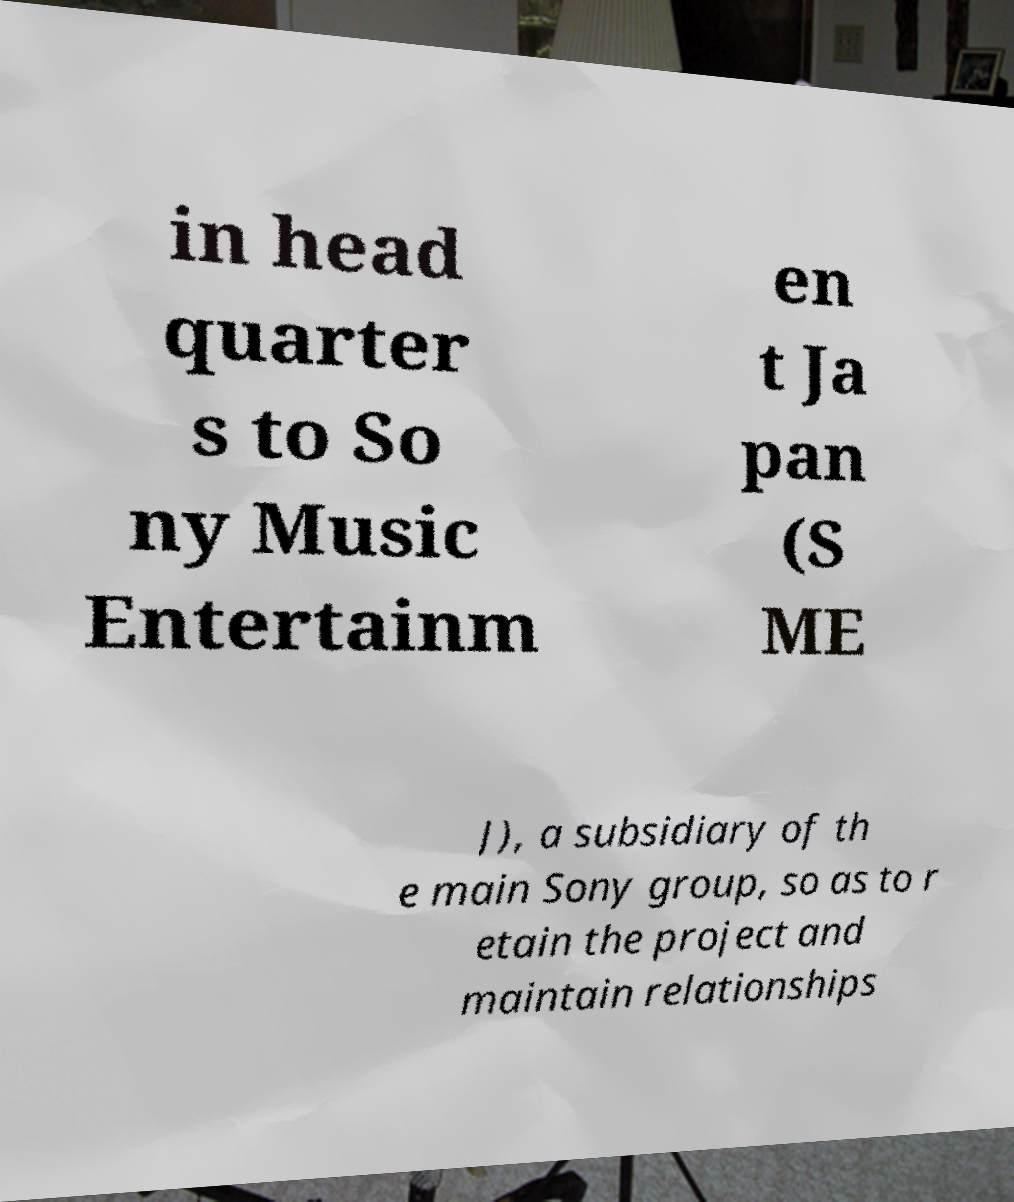What messages or text are displayed in this image? I need them in a readable, typed format. in head quarter s to So ny Music Entertainm en t Ja pan (S ME J), a subsidiary of th e main Sony group, so as to r etain the project and maintain relationships 